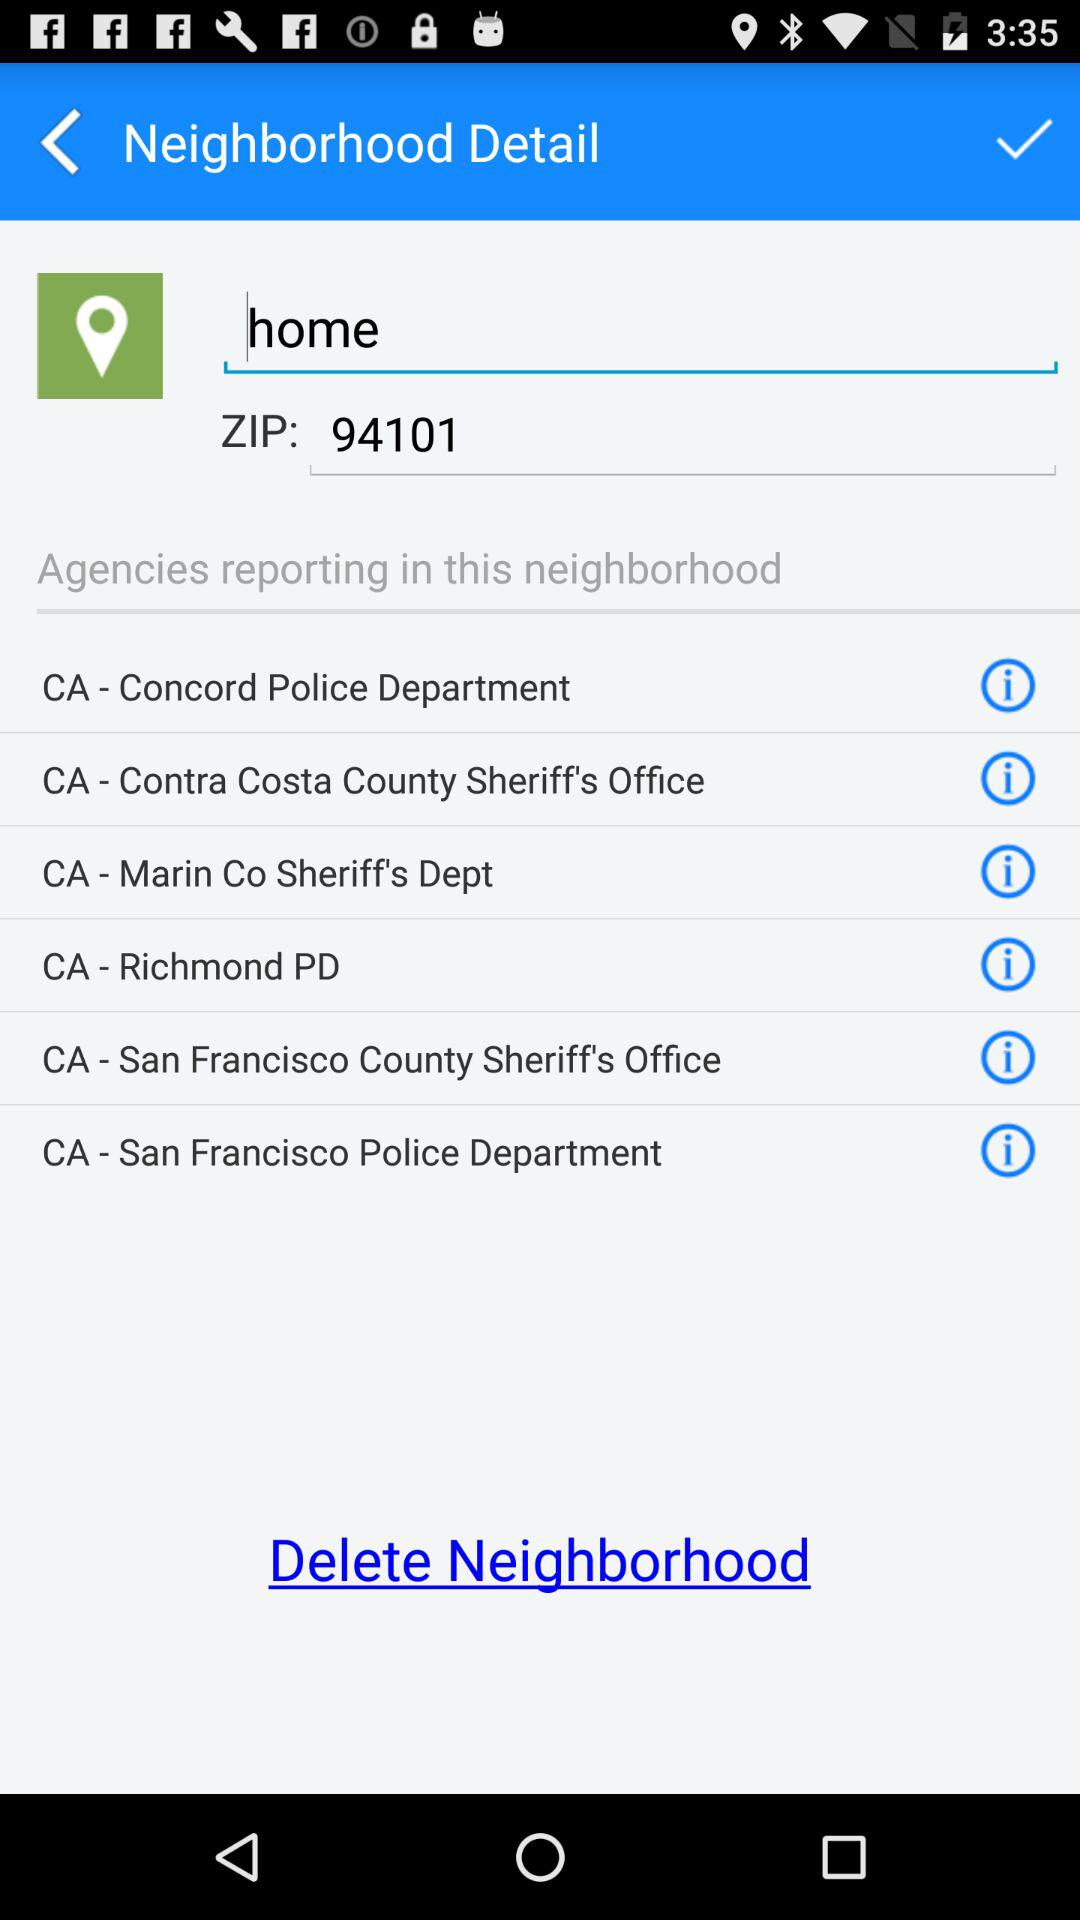What is the application name?
When the provided information is insufficient, respond with <no answer>. <no answer> 